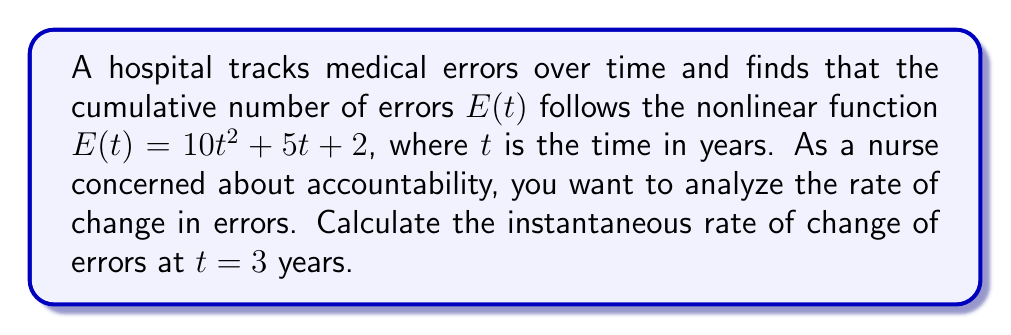Can you solve this math problem? To find the instantaneous rate of change of errors at $t = 3$ years, we need to follow these steps:

1) The function for cumulative errors is given as:
   $$E(t) = 10t^2 + 5t + 2$$

2) To find the rate of change, we need to differentiate $E(t)$ with respect to $t$:
   $$\frac{dE}{dt} = \frac{d}{dt}(10t^2 + 5t + 2)$$

3) Using the power rule and constant rule of differentiation:
   $$\frac{dE}{dt} = 20t + 5$$

4) This derivative represents the instantaneous rate of change of errors at any time $t$.

5) To find the rate at $t = 3$ years, we substitute $t = 3$ into our derivative:
   $$\frac{dE}{dt}\bigg|_{t=3} = 20(3) + 5 = 60 + 5 = 65$$

Therefore, the instantaneous rate of change of errors at $t = 3$ years is 65 errors per year.
Answer: 65 errors/year 